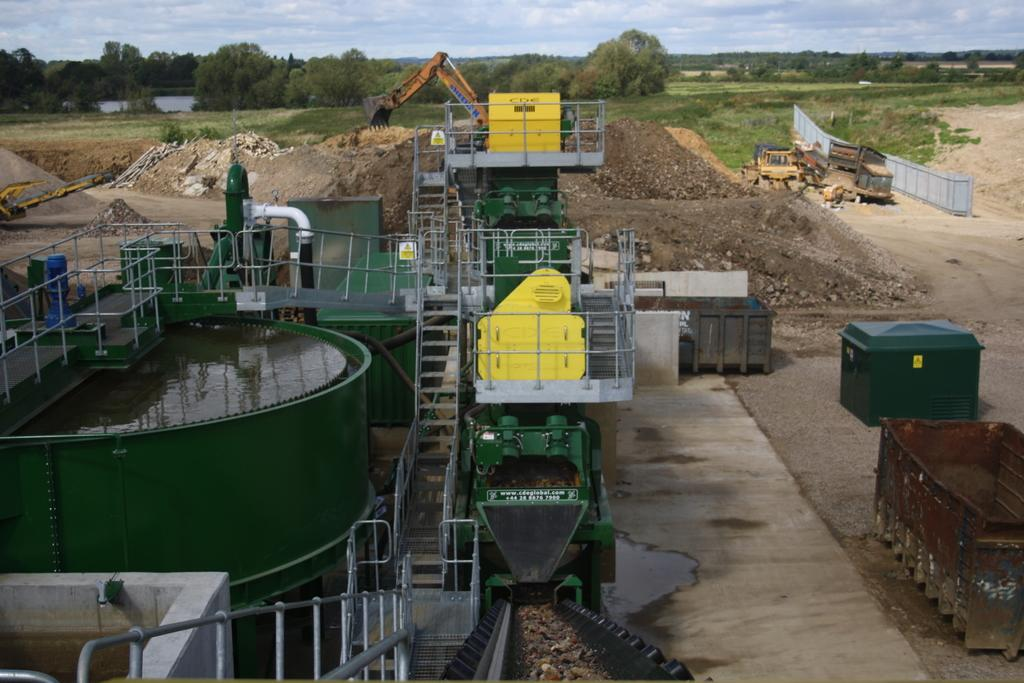What can be seen on the ground in the image? The ground is visible in the image. What type of vehicles are present in the image? There are trucks in the image. What type of natural elements can be seen in the image? There are trees and water visible in the image. What is the color of the object in the image? There is a green colored object in the image. What is visible in the background of the image? The sky is visible in the background of the image. What type of plate is being used to serve the food in the image? There is no plate or food present in the image; it features trucks, trees, water, and a green object. What type of stocking is visible on the person's leg in the image? There is no person or stocking present in the image. 